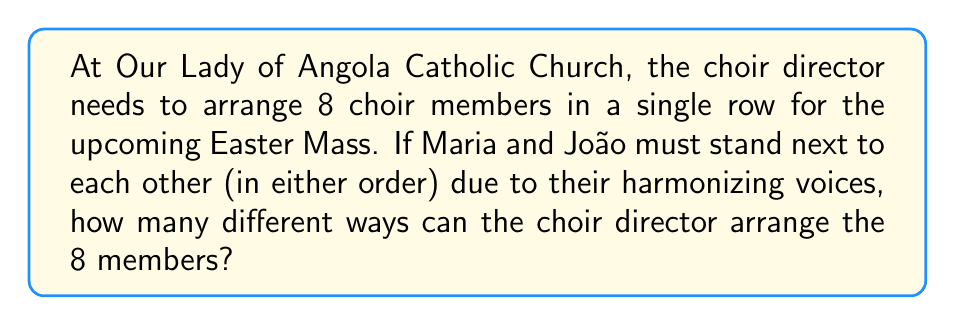Teach me how to tackle this problem. Let's approach this step-by-step:

1) First, consider Maria and João as a single unit. This means we now have 7 units to arrange (the Maria-João unit and the other 6 choir members).

2) We can arrange 7 units in $7!$ ways.

3) However, Maria and João can also swap positions within their unit. This gives us an additional factor of 2.

4) Therefore, the total number of arrangements is:

   $$7! \times 2$$

5) Let's calculate this:

   $$7! \times 2 = 5040 \times 2 = 10080$$

Thus, there are 10,080 different ways to arrange the choir members.
Answer: 10,080 